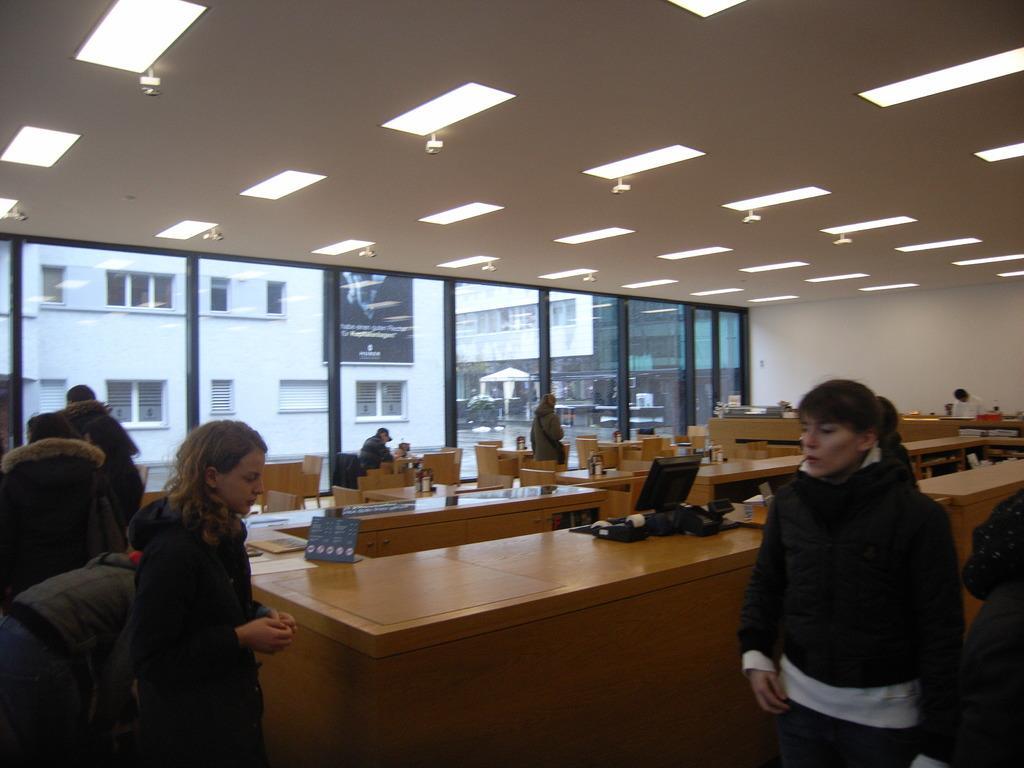Can you describe this image briefly? In this picture there are two women standing. There is a man sitting on a chair. A computer, paper, pamphlet are seen on the table. A woman wearing a bag is standing. There is a person standing on the right side. Few benches and chairs, some lights are visible. A building is in the background. 